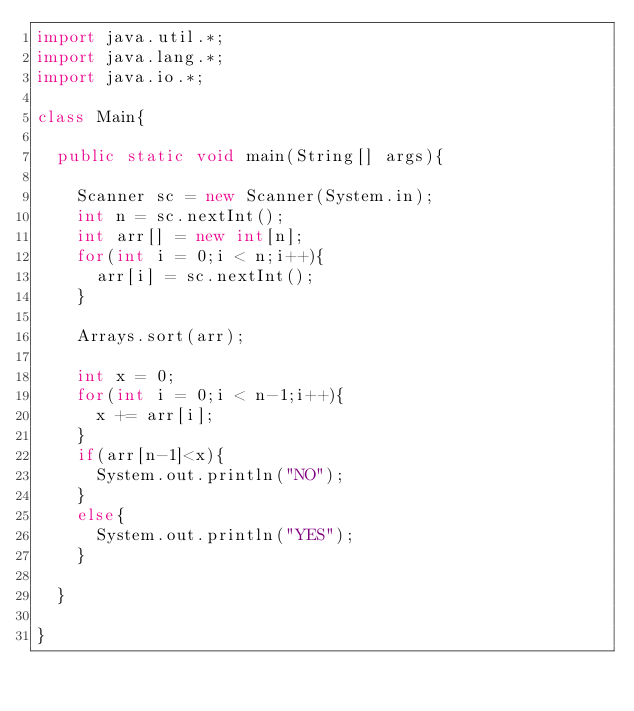<code> <loc_0><loc_0><loc_500><loc_500><_Java_>import java.util.*;
import java.lang.*;
import java.io.*;

class Main{
  
  public static void main(String[] args){
    
    Scanner sc = new Scanner(System.in);
    int n = sc.nextInt();
    int arr[] = new int[n];
    for(int i = 0;i < n;i++){
      arr[i] = sc.nextInt();
    }
    
    Arrays.sort(arr);
    
    int x = 0;
    for(int i = 0;i < n-1;i++){
      x += arr[i];
    }
    if(arr[n-1]<x){
      System.out.println("NO");
    }
    else{
      System.out.println("YES");
    }

  }

}

</code> 